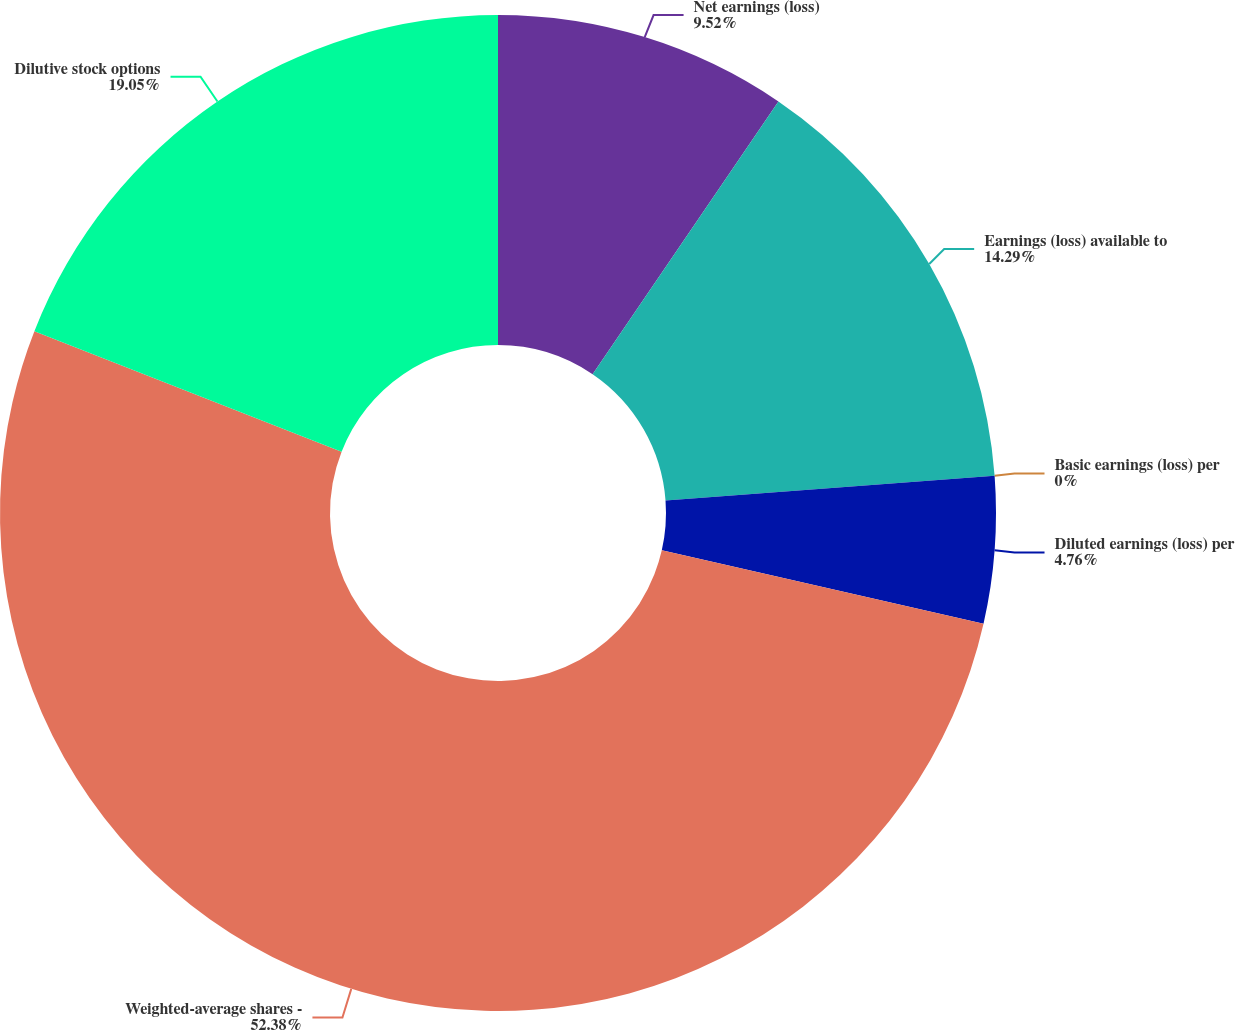<chart> <loc_0><loc_0><loc_500><loc_500><pie_chart><fcel>Net earnings (loss)<fcel>Earnings (loss) available to<fcel>Basic earnings (loss) per<fcel>Diluted earnings (loss) per<fcel>Weighted-average shares -<fcel>Dilutive stock options<nl><fcel>9.52%<fcel>14.29%<fcel>0.0%<fcel>4.76%<fcel>52.38%<fcel>19.05%<nl></chart> 